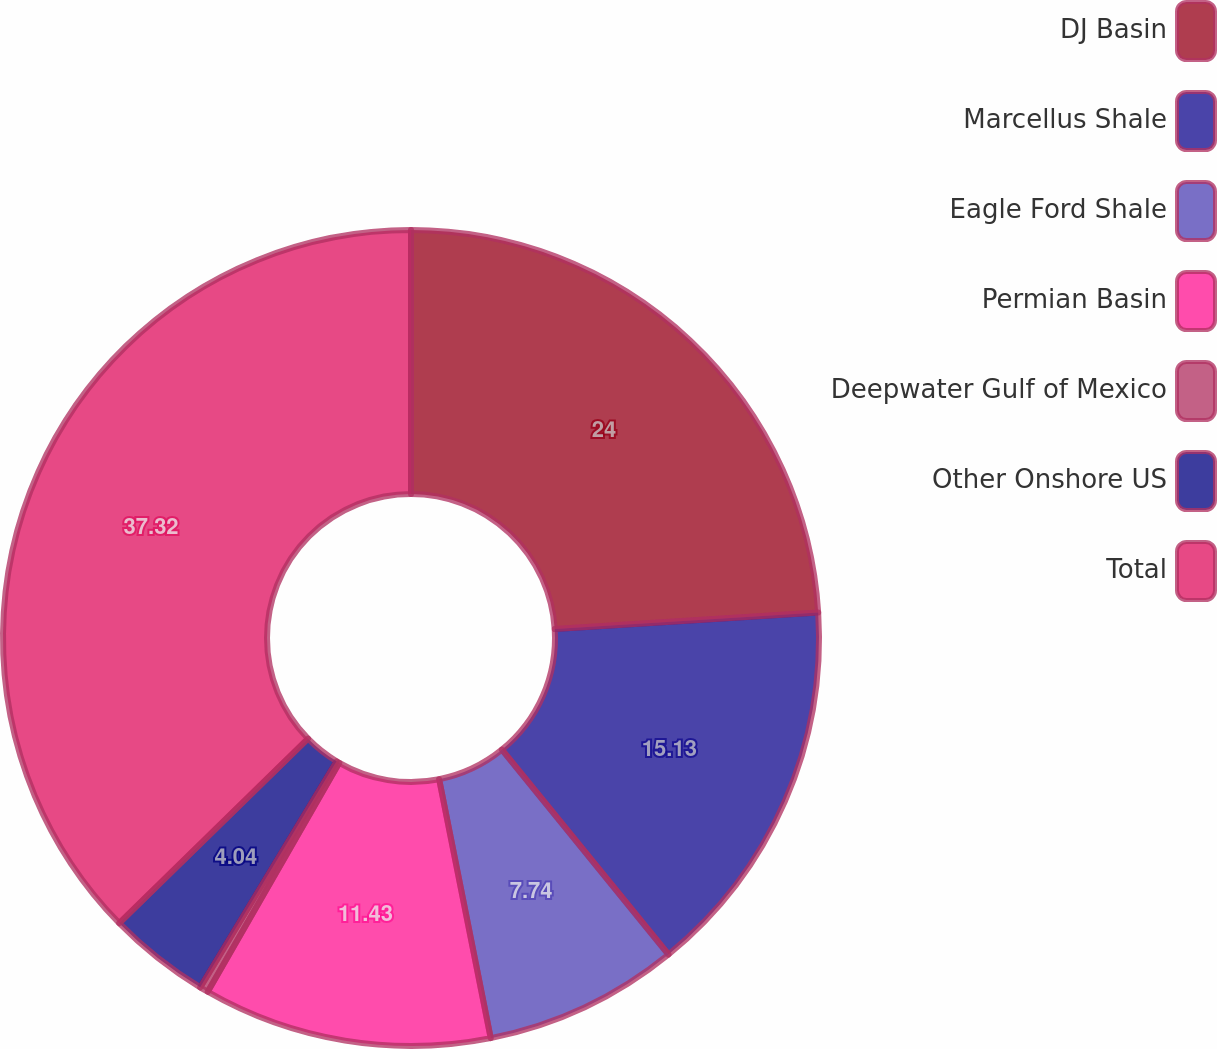Convert chart to OTSL. <chart><loc_0><loc_0><loc_500><loc_500><pie_chart><fcel>DJ Basin<fcel>Marcellus Shale<fcel>Eagle Ford Shale<fcel>Permian Basin<fcel>Deepwater Gulf of Mexico<fcel>Other Onshore US<fcel>Total<nl><fcel>24.0%<fcel>15.13%<fcel>7.74%<fcel>11.43%<fcel>0.34%<fcel>4.04%<fcel>37.32%<nl></chart> 